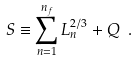<formula> <loc_0><loc_0><loc_500><loc_500>S \equiv \sum _ { n = 1 } ^ { n _ { f } } L _ { n } ^ { 2 / 3 } + Q \ .</formula> 